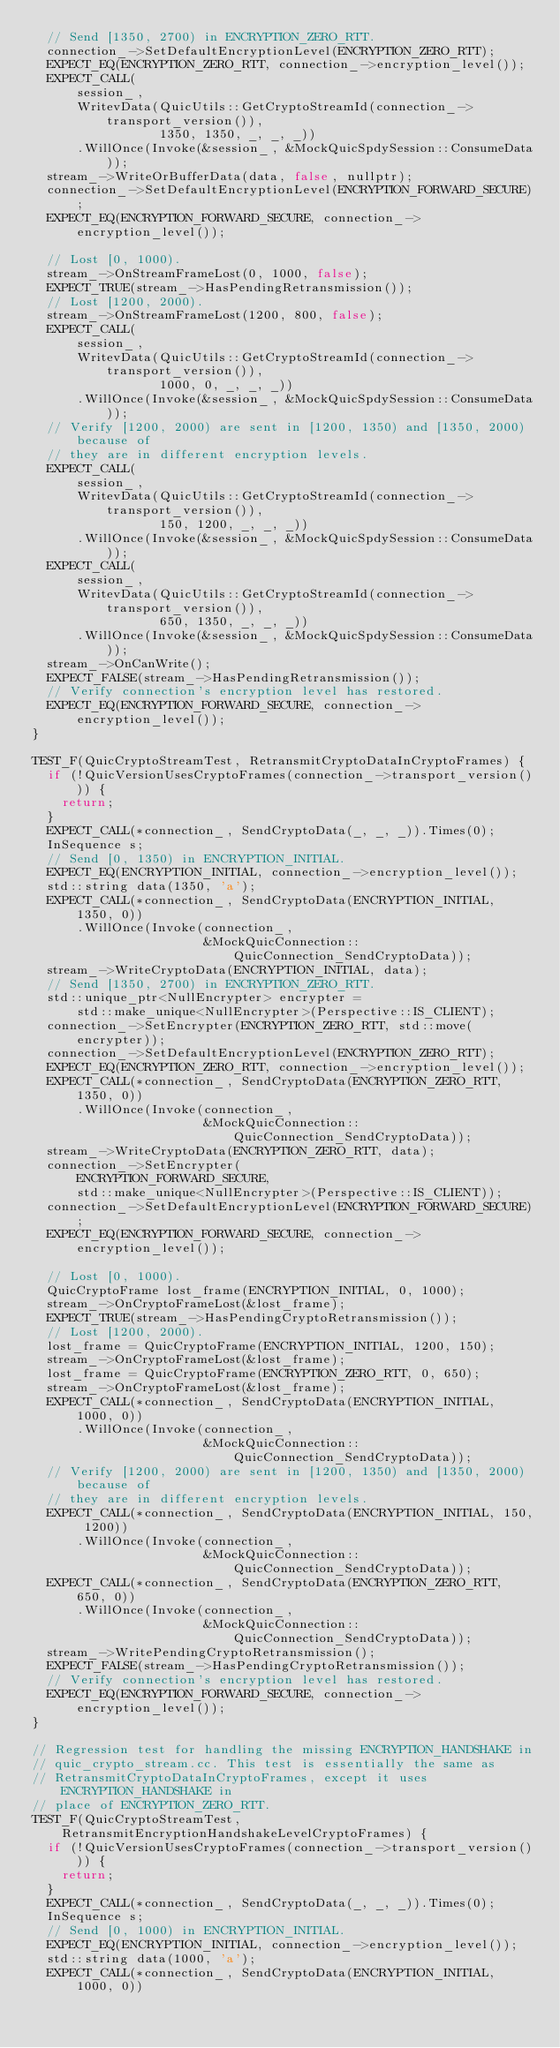Convert code to text. <code><loc_0><loc_0><loc_500><loc_500><_C++_>  // Send [1350, 2700) in ENCRYPTION_ZERO_RTT.
  connection_->SetDefaultEncryptionLevel(ENCRYPTION_ZERO_RTT);
  EXPECT_EQ(ENCRYPTION_ZERO_RTT, connection_->encryption_level());
  EXPECT_CALL(
      session_,
      WritevData(QuicUtils::GetCryptoStreamId(connection_->transport_version()),
                 1350, 1350, _, _, _))
      .WillOnce(Invoke(&session_, &MockQuicSpdySession::ConsumeData));
  stream_->WriteOrBufferData(data, false, nullptr);
  connection_->SetDefaultEncryptionLevel(ENCRYPTION_FORWARD_SECURE);
  EXPECT_EQ(ENCRYPTION_FORWARD_SECURE, connection_->encryption_level());

  // Lost [0, 1000).
  stream_->OnStreamFrameLost(0, 1000, false);
  EXPECT_TRUE(stream_->HasPendingRetransmission());
  // Lost [1200, 2000).
  stream_->OnStreamFrameLost(1200, 800, false);
  EXPECT_CALL(
      session_,
      WritevData(QuicUtils::GetCryptoStreamId(connection_->transport_version()),
                 1000, 0, _, _, _))
      .WillOnce(Invoke(&session_, &MockQuicSpdySession::ConsumeData));
  // Verify [1200, 2000) are sent in [1200, 1350) and [1350, 2000) because of
  // they are in different encryption levels.
  EXPECT_CALL(
      session_,
      WritevData(QuicUtils::GetCryptoStreamId(connection_->transport_version()),
                 150, 1200, _, _, _))
      .WillOnce(Invoke(&session_, &MockQuicSpdySession::ConsumeData));
  EXPECT_CALL(
      session_,
      WritevData(QuicUtils::GetCryptoStreamId(connection_->transport_version()),
                 650, 1350, _, _, _))
      .WillOnce(Invoke(&session_, &MockQuicSpdySession::ConsumeData));
  stream_->OnCanWrite();
  EXPECT_FALSE(stream_->HasPendingRetransmission());
  // Verify connection's encryption level has restored.
  EXPECT_EQ(ENCRYPTION_FORWARD_SECURE, connection_->encryption_level());
}

TEST_F(QuicCryptoStreamTest, RetransmitCryptoDataInCryptoFrames) {
  if (!QuicVersionUsesCryptoFrames(connection_->transport_version())) {
    return;
  }
  EXPECT_CALL(*connection_, SendCryptoData(_, _, _)).Times(0);
  InSequence s;
  // Send [0, 1350) in ENCRYPTION_INITIAL.
  EXPECT_EQ(ENCRYPTION_INITIAL, connection_->encryption_level());
  std::string data(1350, 'a');
  EXPECT_CALL(*connection_, SendCryptoData(ENCRYPTION_INITIAL, 1350, 0))
      .WillOnce(Invoke(connection_,
                       &MockQuicConnection::QuicConnection_SendCryptoData));
  stream_->WriteCryptoData(ENCRYPTION_INITIAL, data);
  // Send [1350, 2700) in ENCRYPTION_ZERO_RTT.
  std::unique_ptr<NullEncrypter> encrypter =
      std::make_unique<NullEncrypter>(Perspective::IS_CLIENT);
  connection_->SetEncrypter(ENCRYPTION_ZERO_RTT, std::move(encrypter));
  connection_->SetDefaultEncryptionLevel(ENCRYPTION_ZERO_RTT);
  EXPECT_EQ(ENCRYPTION_ZERO_RTT, connection_->encryption_level());
  EXPECT_CALL(*connection_, SendCryptoData(ENCRYPTION_ZERO_RTT, 1350, 0))
      .WillOnce(Invoke(connection_,
                       &MockQuicConnection::QuicConnection_SendCryptoData));
  stream_->WriteCryptoData(ENCRYPTION_ZERO_RTT, data);
  connection_->SetEncrypter(
      ENCRYPTION_FORWARD_SECURE,
      std::make_unique<NullEncrypter>(Perspective::IS_CLIENT));
  connection_->SetDefaultEncryptionLevel(ENCRYPTION_FORWARD_SECURE);
  EXPECT_EQ(ENCRYPTION_FORWARD_SECURE, connection_->encryption_level());

  // Lost [0, 1000).
  QuicCryptoFrame lost_frame(ENCRYPTION_INITIAL, 0, 1000);
  stream_->OnCryptoFrameLost(&lost_frame);
  EXPECT_TRUE(stream_->HasPendingCryptoRetransmission());
  // Lost [1200, 2000).
  lost_frame = QuicCryptoFrame(ENCRYPTION_INITIAL, 1200, 150);
  stream_->OnCryptoFrameLost(&lost_frame);
  lost_frame = QuicCryptoFrame(ENCRYPTION_ZERO_RTT, 0, 650);
  stream_->OnCryptoFrameLost(&lost_frame);
  EXPECT_CALL(*connection_, SendCryptoData(ENCRYPTION_INITIAL, 1000, 0))
      .WillOnce(Invoke(connection_,
                       &MockQuicConnection::QuicConnection_SendCryptoData));
  // Verify [1200, 2000) are sent in [1200, 1350) and [1350, 2000) because of
  // they are in different encryption levels.
  EXPECT_CALL(*connection_, SendCryptoData(ENCRYPTION_INITIAL, 150, 1200))
      .WillOnce(Invoke(connection_,
                       &MockQuicConnection::QuicConnection_SendCryptoData));
  EXPECT_CALL(*connection_, SendCryptoData(ENCRYPTION_ZERO_RTT, 650, 0))
      .WillOnce(Invoke(connection_,
                       &MockQuicConnection::QuicConnection_SendCryptoData));
  stream_->WritePendingCryptoRetransmission();
  EXPECT_FALSE(stream_->HasPendingCryptoRetransmission());
  // Verify connection's encryption level has restored.
  EXPECT_EQ(ENCRYPTION_FORWARD_SECURE, connection_->encryption_level());
}

// Regression test for handling the missing ENCRYPTION_HANDSHAKE in
// quic_crypto_stream.cc. This test is essentially the same as
// RetransmitCryptoDataInCryptoFrames, except it uses ENCRYPTION_HANDSHAKE in
// place of ENCRYPTION_ZERO_RTT.
TEST_F(QuicCryptoStreamTest, RetransmitEncryptionHandshakeLevelCryptoFrames) {
  if (!QuicVersionUsesCryptoFrames(connection_->transport_version())) {
    return;
  }
  EXPECT_CALL(*connection_, SendCryptoData(_, _, _)).Times(0);
  InSequence s;
  // Send [0, 1000) in ENCRYPTION_INITIAL.
  EXPECT_EQ(ENCRYPTION_INITIAL, connection_->encryption_level());
  std::string data(1000, 'a');
  EXPECT_CALL(*connection_, SendCryptoData(ENCRYPTION_INITIAL, 1000, 0))</code> 